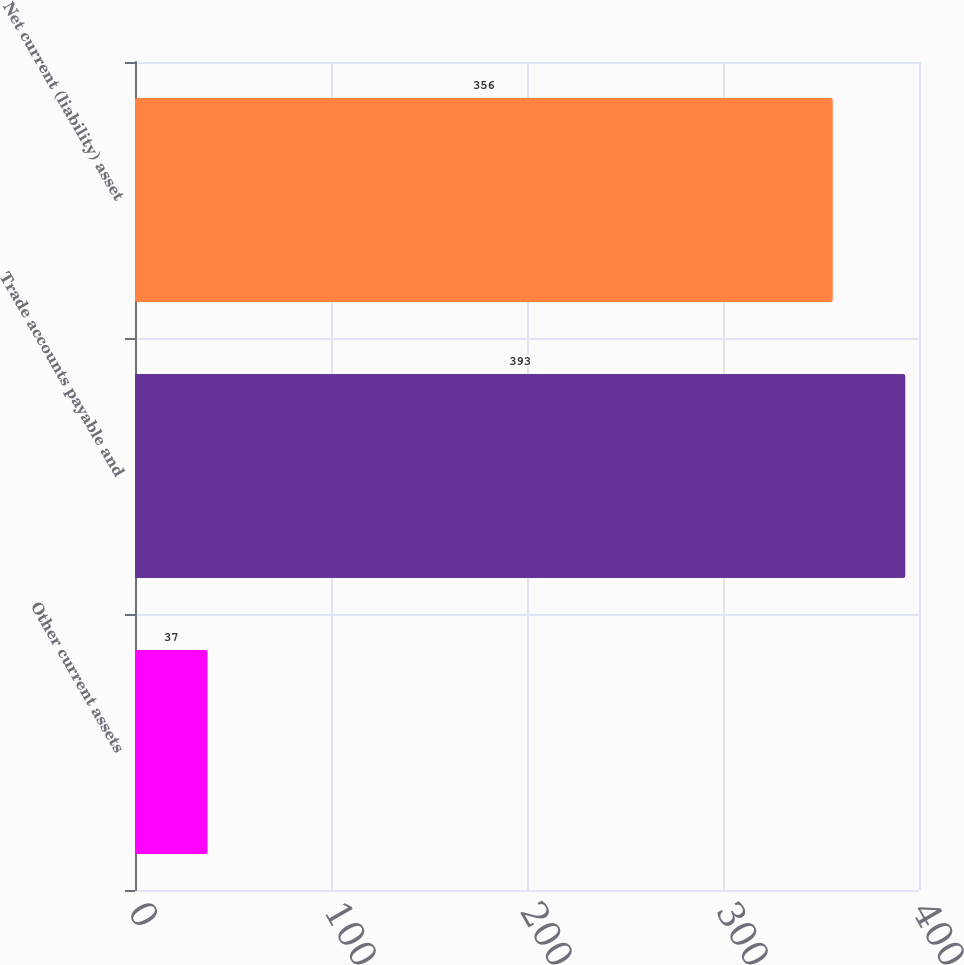Convert chart. <chart><loc_0><loc_0><loc_500><loc_500><bar_chart><fcel>Other current assets<fcel>Trade accounts payable and<fcel>Net current (liability) asset<nl><fcel>37<fcel>393<fcel>356<nl></chart> 